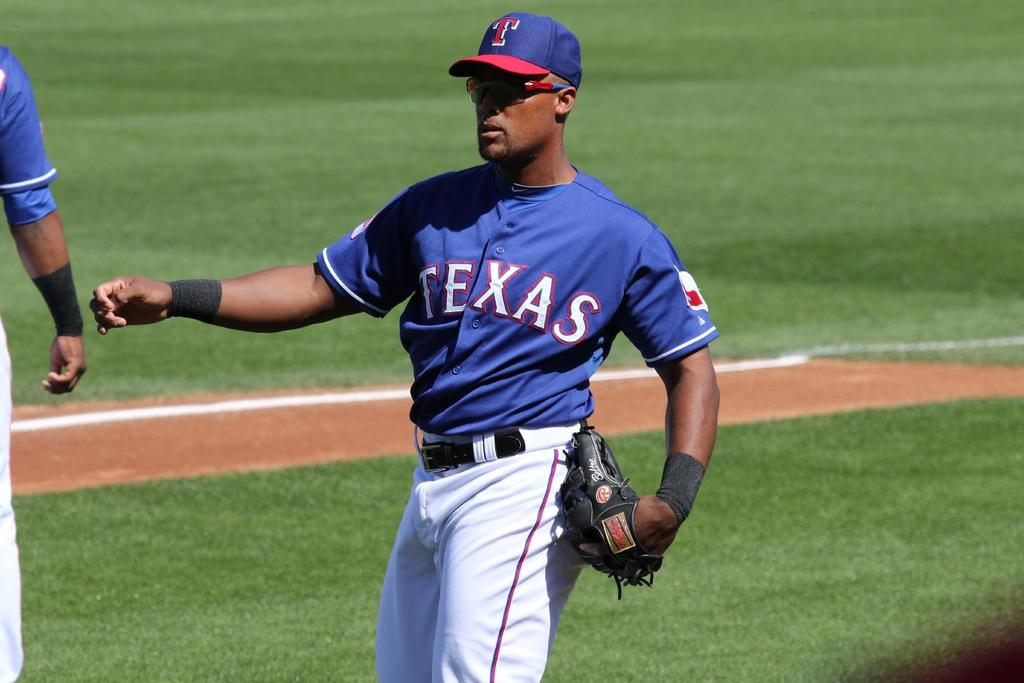<image>
Relay a brief, clear account of the picture shown. A man wearing a Texas baseball uniform is walking on the field. 